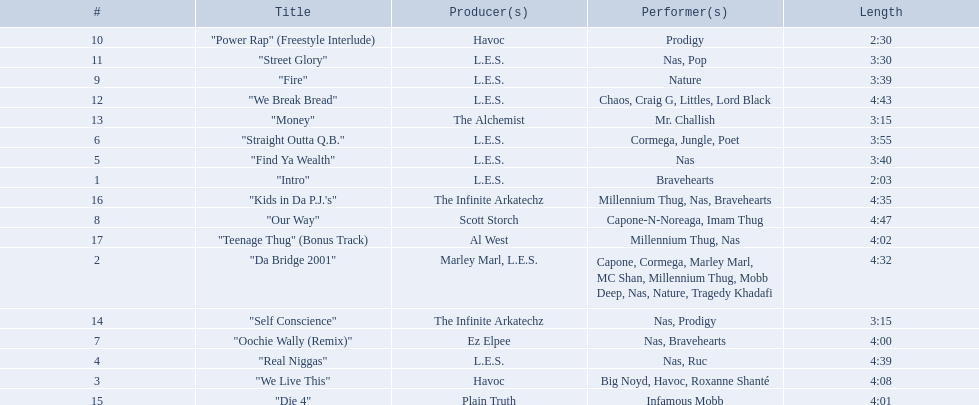How long is each song? 2:03, 4:32, 4:08, 4:39, 3:40, 3:55, 4:00, 4:47, 3:39, 2:30, 3:30, 4:43, 3:15, 3:15, 4:01, 4:35, 4:02. What length is the longest? 4:47. 